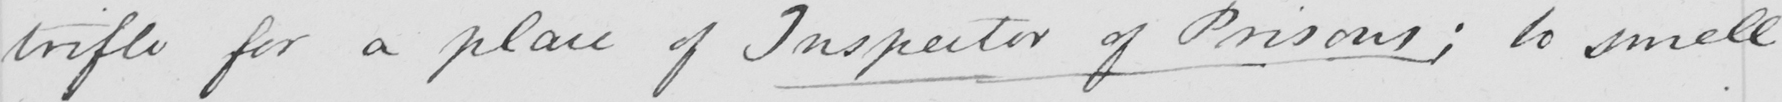Please transcribe the handwritten text in this image. trifle for a place of Inspector of Prisons ; to smell 